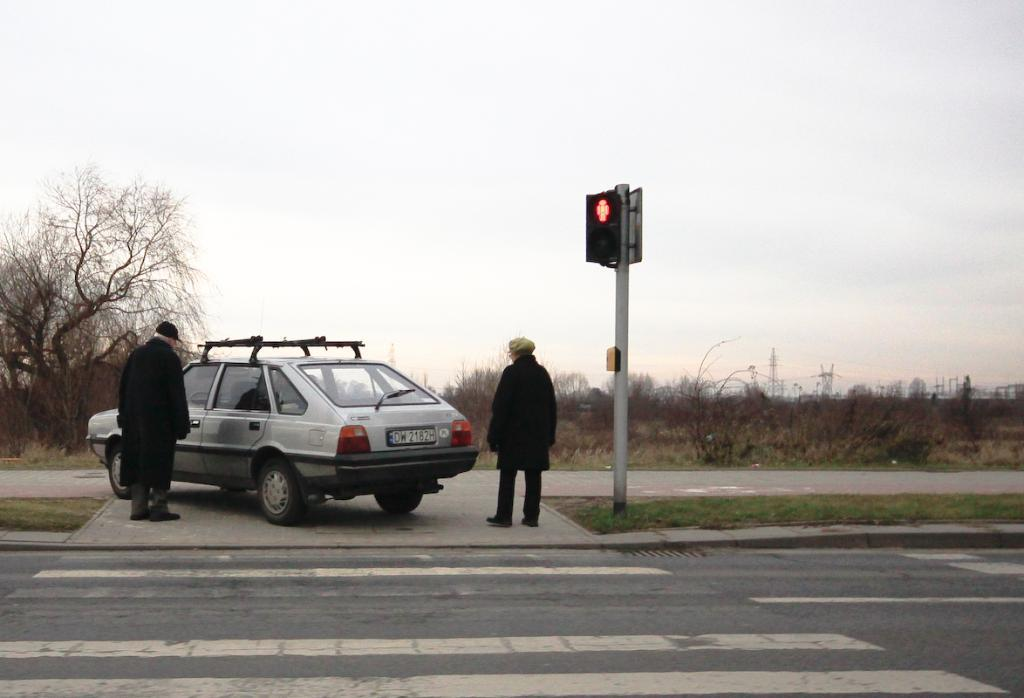How many people are in the image? There are two persons standing in the image. What else can be seen in the image besides the people? There is a vehicle, signal lights on a pole, plants, trees, cell towers, and the sky visible in the background of the image. What type of seed is being planted by the person in the image? There is no person planting a seed in the image; the image does not show any planting activity. 